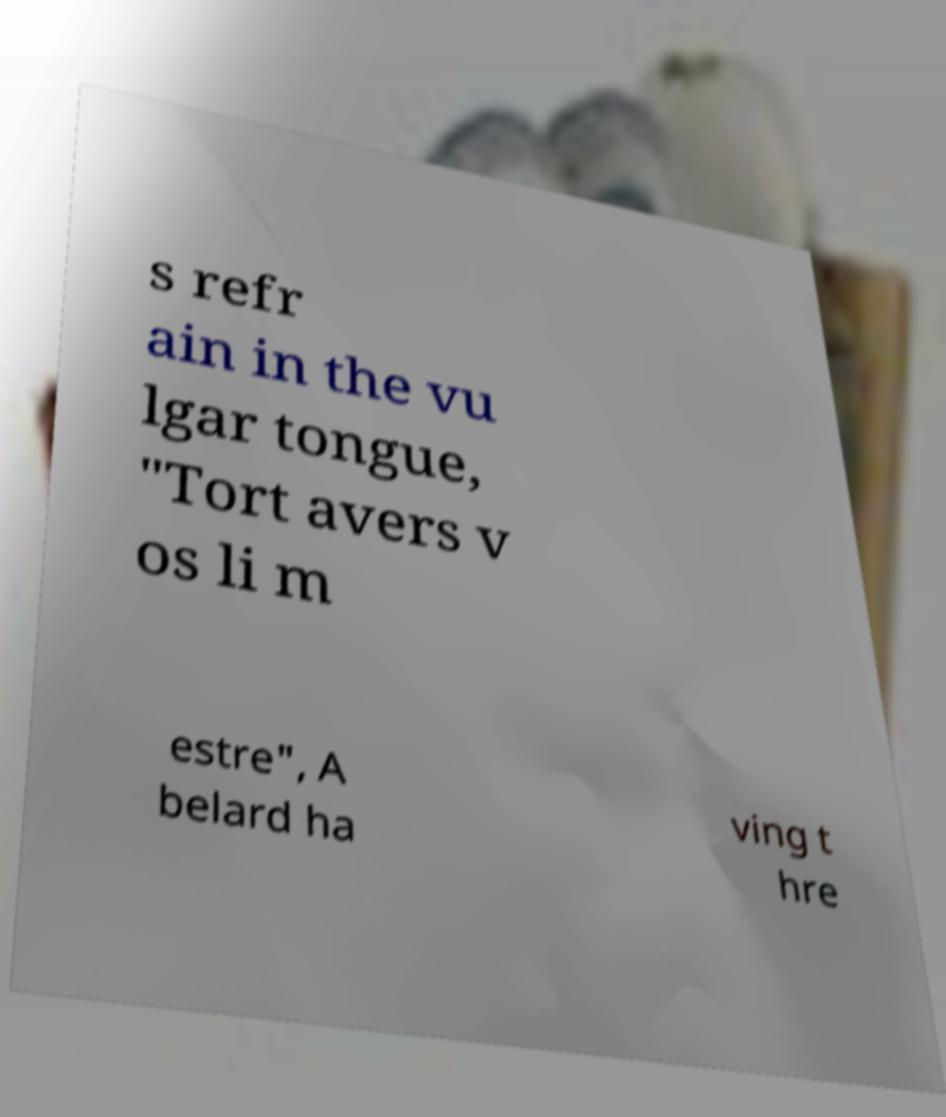There's text embedded in this image that I need extracted. Can you transcribe it verbatim? s refr ain in the vu lgar tongue, "Tort avers v os li m estre", A belard ha ving t hre 